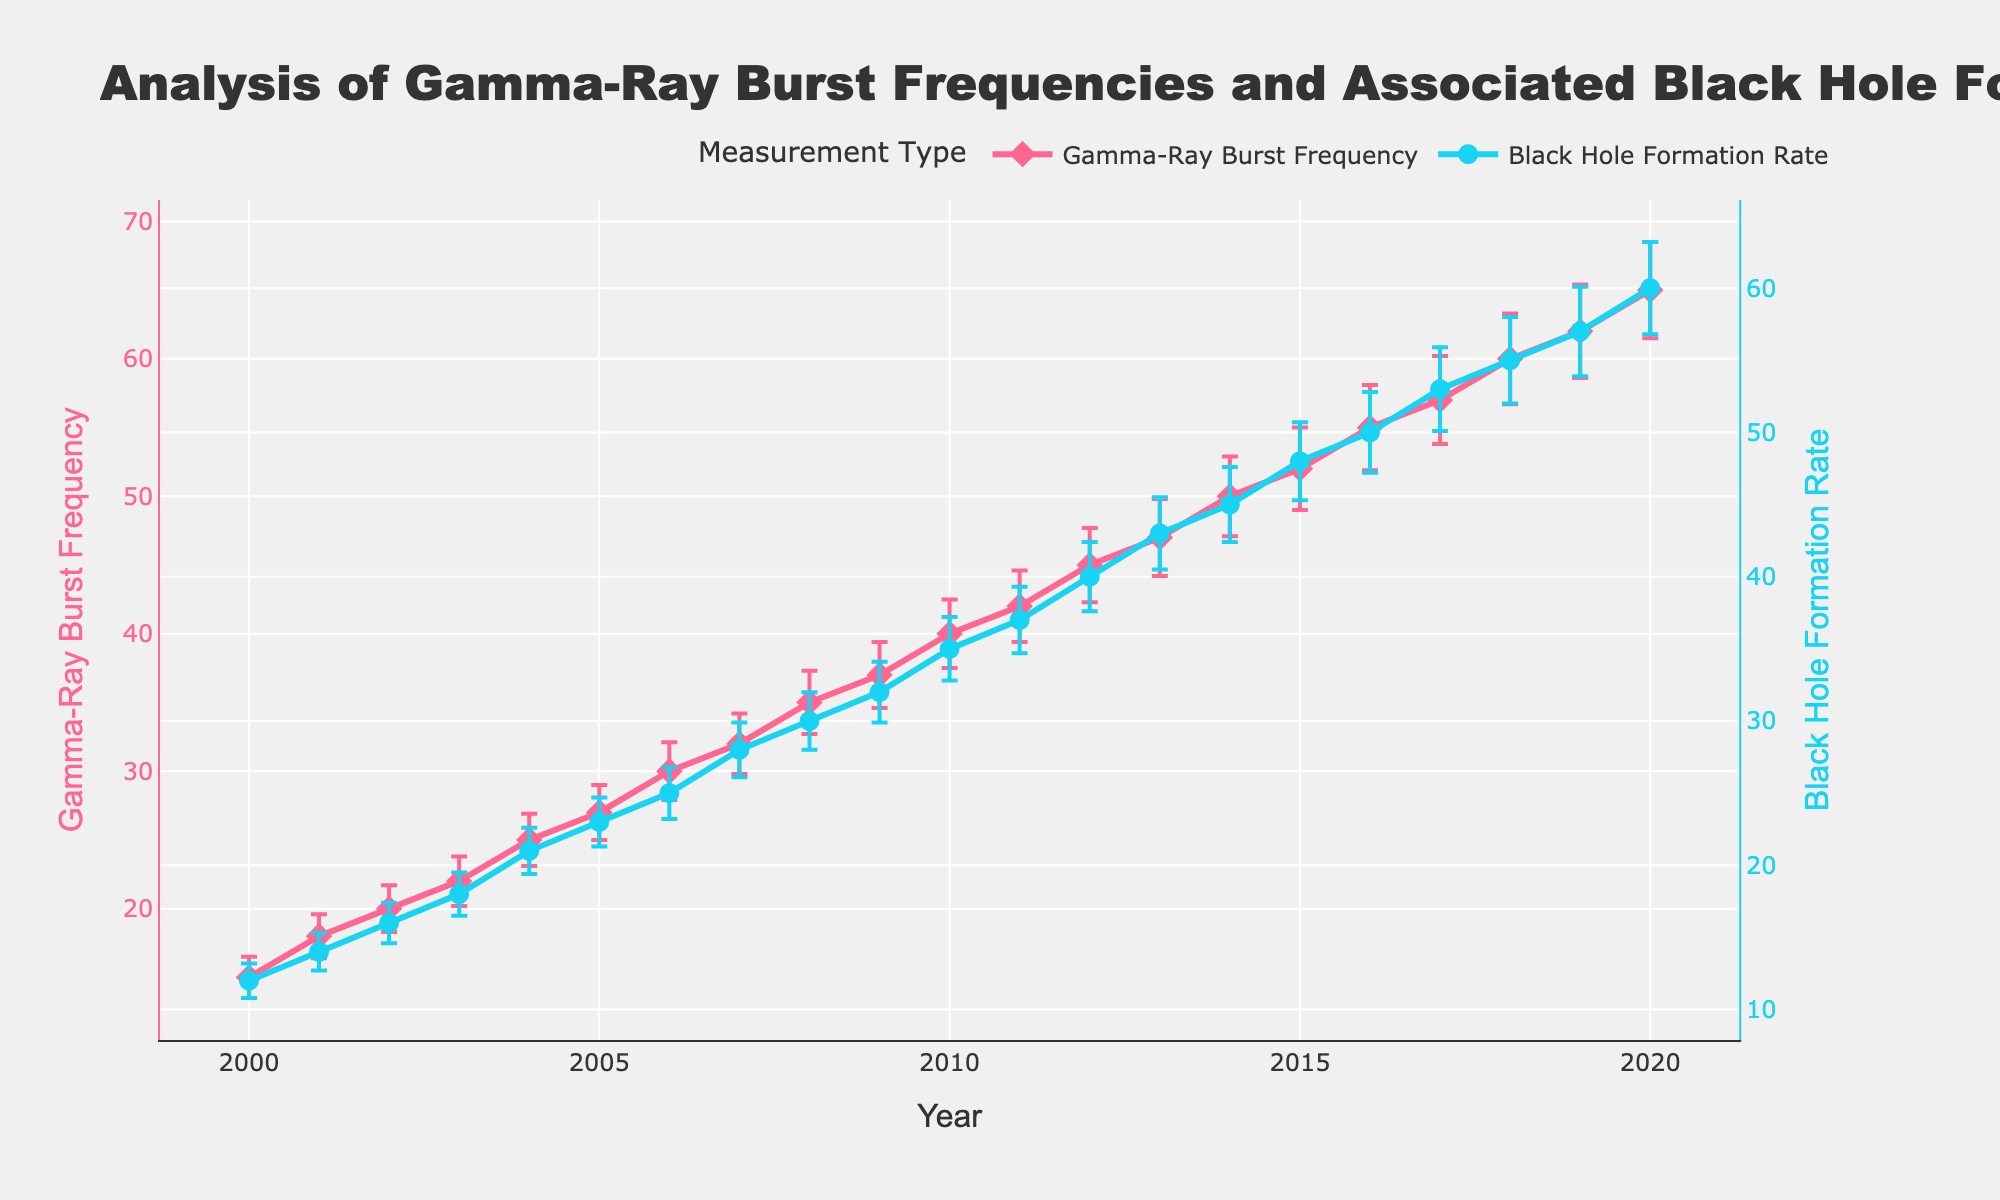What is the title of the figure? Look at the top of the plot where the title is clearly written. The title provides a summary of what the figure represents.
Answer: Analysis of Gamma-Ray Burst Frequencies and Associated Black Hole Formations over Time What is the value of the Gamma-Ray Burst Frequency in the year 2010? Locate the year 2010 on the x-axis and observe the corresponding point on the Gamma-Ray Burst Frequency line (plotted in pink with diamond markers). Read the value at this point.
Answer: 40 How does the trend in Black Hole Formation Rates compare to the trend in Gamma-Ray Burst Frequencies over time? Observe the overall trends of both lines separately. Compare both lines' slopes (upward, downward, or constant) over the years to understand how they change together or individually.
Answer: Both trends show an increasing pattern over time What is the difference between the Gamma-Ray Burst Frequency and Black Hole Formation Rate in 2020? Locate the year 2020 on the x-axis and find the corresponding values for both Gamma-Ray Burst Frequency and Black Hole Formation Rate. Subtract the Black Hole Formation Rate from the Gamma-Ray Burst Frequency value.
Answer: 65 - 60 = 5 Which year had the highest Black Hole Formation Rate? Observe the points on the Blue line (Black Hole Formation Rate) to find the year with the highest value.
Answer: 2020 What is the average Gamma-Ray Burst Frequency from 2000 to 2020? Sum the Gamma-Ray Burst Frequency values from 2000 to 2020 and then divide by the number of years (21 years) to find the average.
Answer: (15+18+20+22+25+27+30+32+35+37+40+42+45+47+50+52+55+57+60+62+65)/21 = 38.4 In which year did the Gamma-Ray Burst Frequency and Black Hole Formation Rate both have an error bar of the same length? Analyze the error bars on both lines. Compare their lengths year by year to find where they are equal in length.
Answer: 2003 What can you infer about the relationship between Gamma-Ray Burst Frequencies and Black Hole Formations based on their trends and error bars? Look at the parallel trend lines, and error bars. Higher Gamma-Ray Burst Frequencies seem to coincide with higher Black Hole Formation Rates and the error bars' similarity may indicate related uncertainties or measurements.
Answer: A positive correlation with similar uncertainty levels What is the color of the line representing Gamma-Ray Burst Frequency? Look at the visual characteristics of the plot. Determine the color of the line that represents Gamma-Ray Burst Frequency.
Answer: Pink In which year did Gamma-Ray Burst Frequency see the largest increase from the previous year? Calculate the yearly differences of Gamma-Ray Burst Frequencies and identify the maximum change.
Answer: 2017-2018, increase from 57 to 60 is 3 